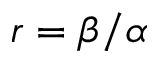Convert formula to latex. <formula><loc_0><loc_0><loc_500><loc_500>r = \beta / \alpha</formula> 